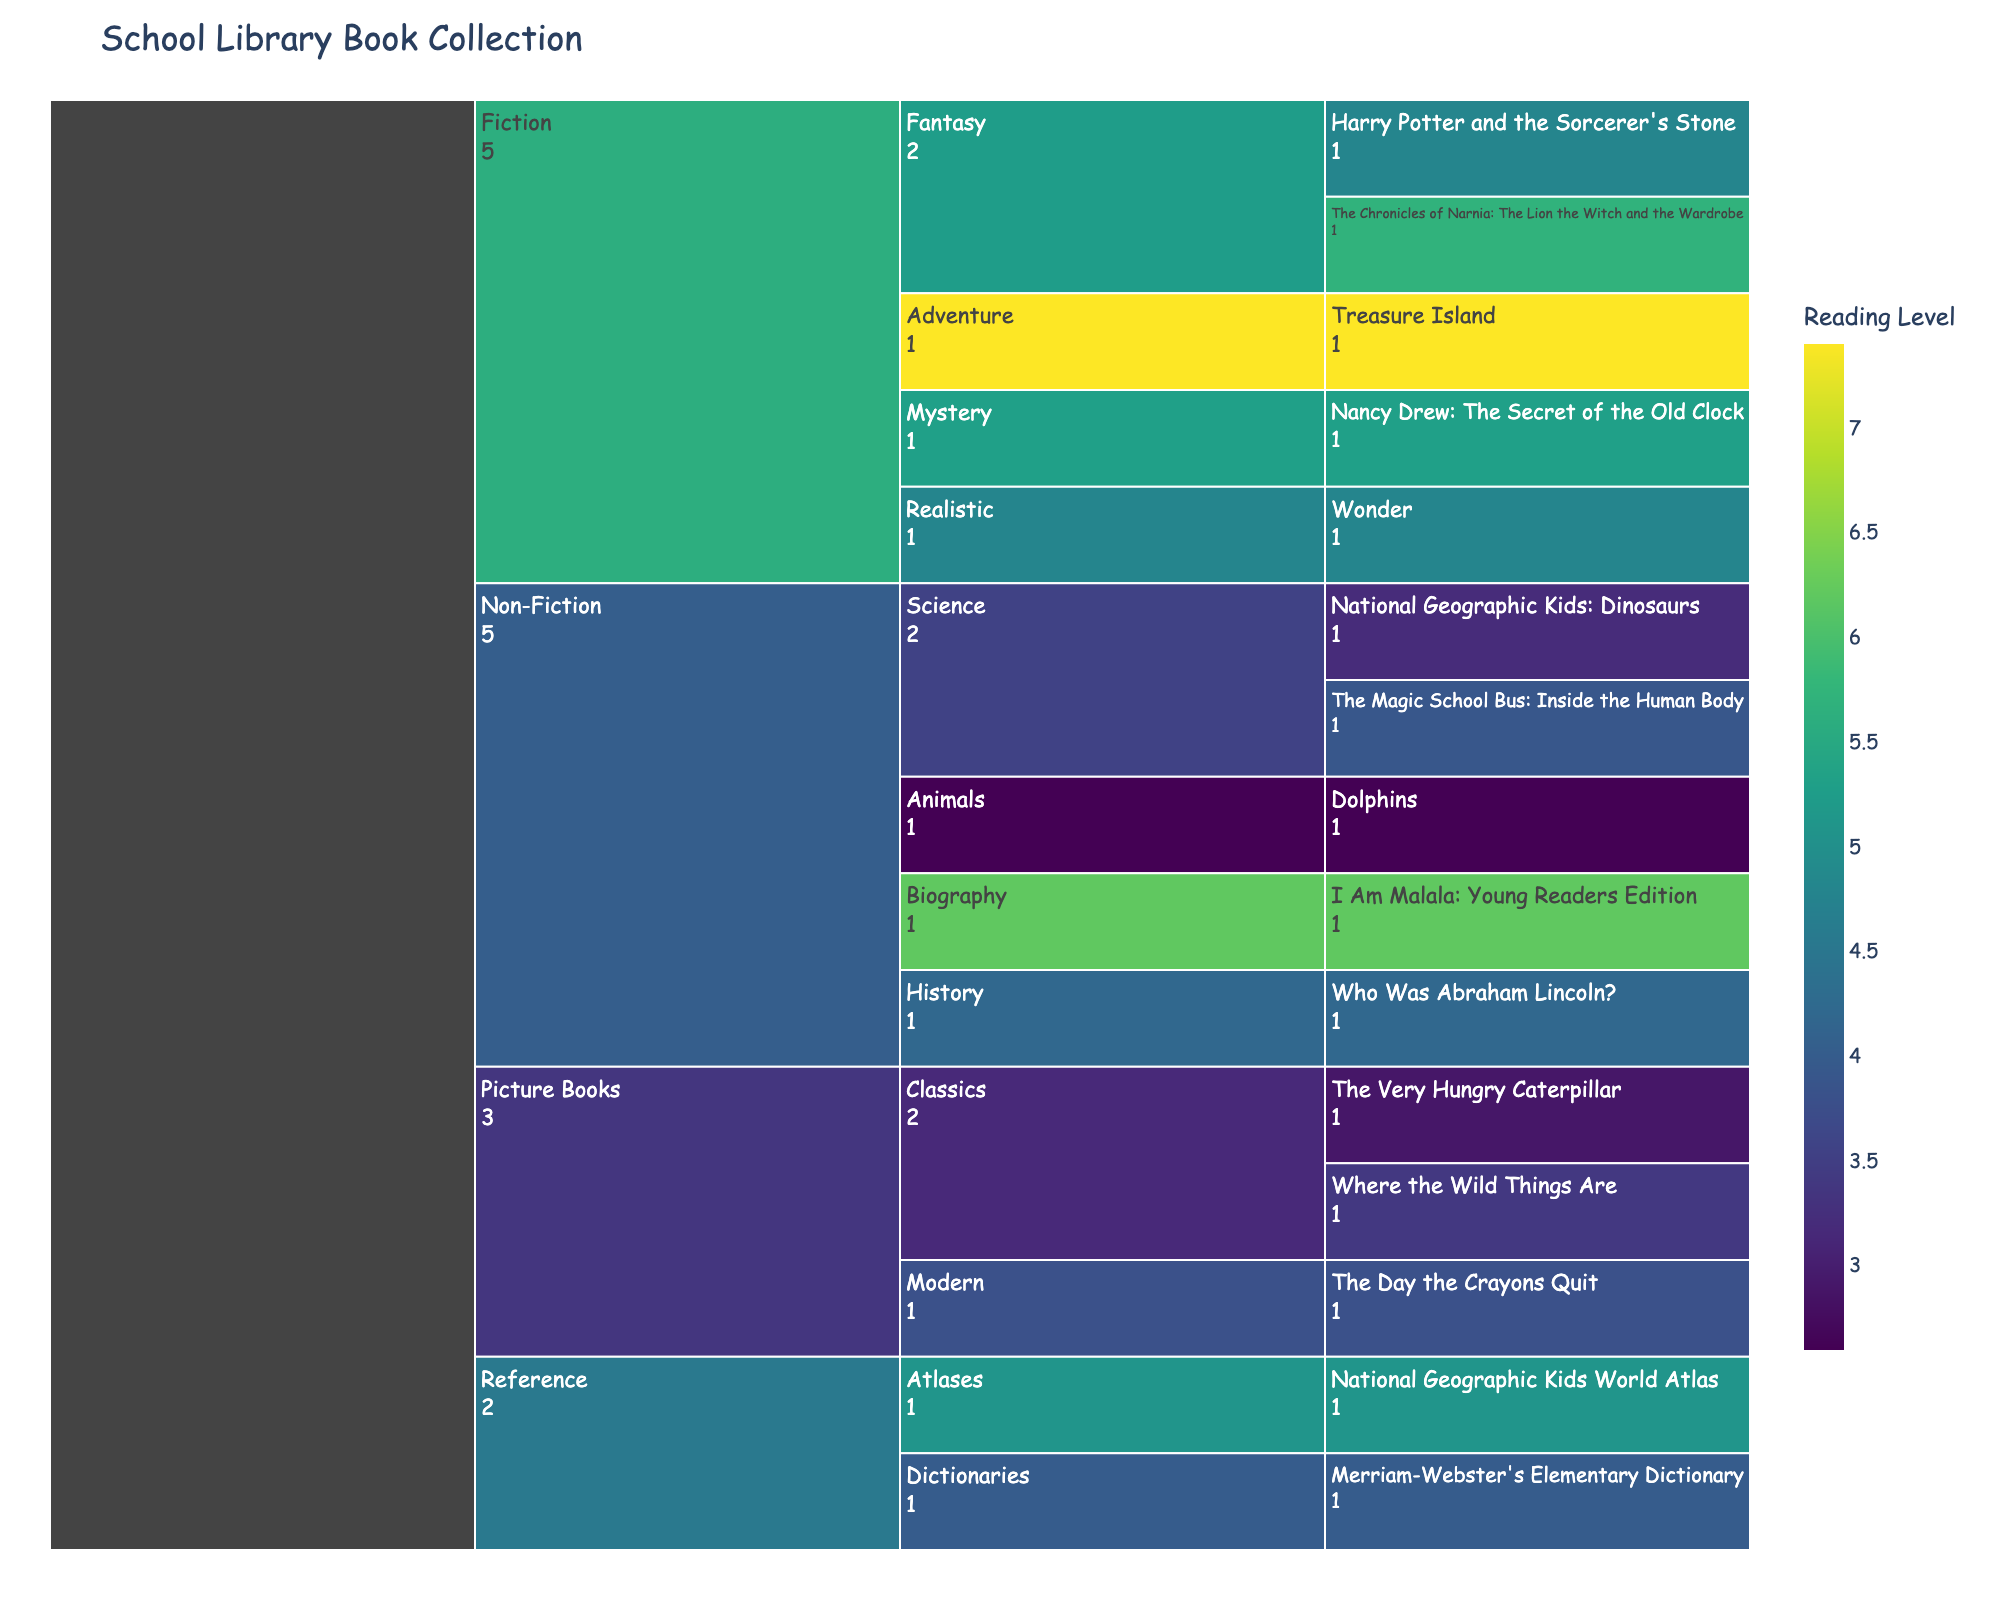What is the title of the icicle chart? The title is usually located at the top of the chart and provides an overview of what the chart represents. By reading the title, we can understand the subject of the chart.
Answer: School Library Book Collection What color scale is used to represent the reading levels? The color scale represents the reading levels, helping to visually distinguish different books based on their reading difficulty. The specific color scale becomes clear by observing the gradient and the color legend.
Answer: Viridis Which category under Fiction has the highest reading level book? To find this, we look at the "Fiction" category and then examine each sub-category for the highest reading level. The "Adventure" category has the book "Treasure Island" with a reading level of 7.4.
Answer: Adventure How many books are there under the Non-Fiction category? To find the number of books under the Non-Fiction category, we count each leaf node (individual book) under this category.
Answer: 5 What is the average reading level of the Picture Books category? First, identify the reading levels of all books under the "Picture Books" category and then calculate the average. The reading levels are 3.4, 2.9, and 3.8. Sum these (3.4 + 2.9 + 3.8 = 10.1) and divide by the number of books (10.1 / 3).
Answer: 3.37 Which subject has the lowest reading level book? To determine this, we scan all categories for the book with the lowest reading level, which is "Dolphins" in the "Non-Fiction -> Animals" category with a reading level of 2.6.
Answer: Non-Fiction Which sub-category under Non-Fiction has the highest average reading level? Calculate the average reading levels for each sub-category within Non-Fiction:
- Science (3.2, 3.9): (3.2+3.9)/2 = 3.55
- History: 4.2
- Biography: 6.2
- Animals: 2.6
The highest average is in the "Biography" sub-category.
Answer: Biography How does the number of books in Fiction compare to Non-Fiction? By counting the number of books (leaf nodes) in each category, we find Fiction has 5 books and Non-Fiction also has 5 books.
Answer: Equal Which book has the highest reading level and in which category does it belong? By examining the color and reading level values, we find "Treasure Island" with the highest reading level of 7.4, located in the "Fiction -> Adventure" category.
Answer: Treasure Island (Adventure) What is the total number of books in the collection? To find the total, sum all the books across all categories by counting each leaf node in the chart.
Answer: 15 